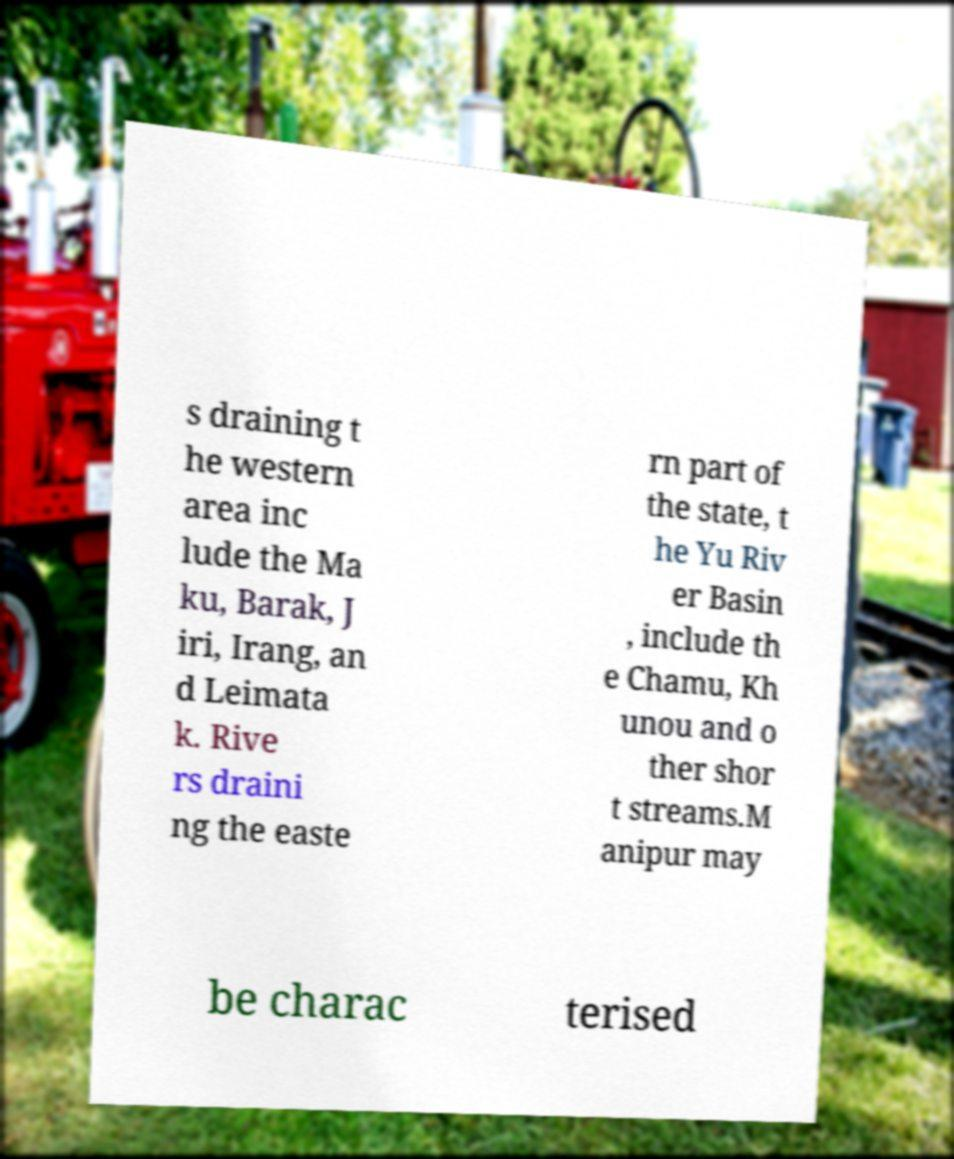For documentation purposes, I need the text within this image transcribed. Could you provide that? s draining t he western area inc lude the Ma ku, Barak, J iri, Irang, an d Leimata k. Rive rs draini ng the easte rn part of the state, t he Yu Riv er Basin , include th e Chamu, Kh unou and o ther shor t streams.M anipur may be charac terised 